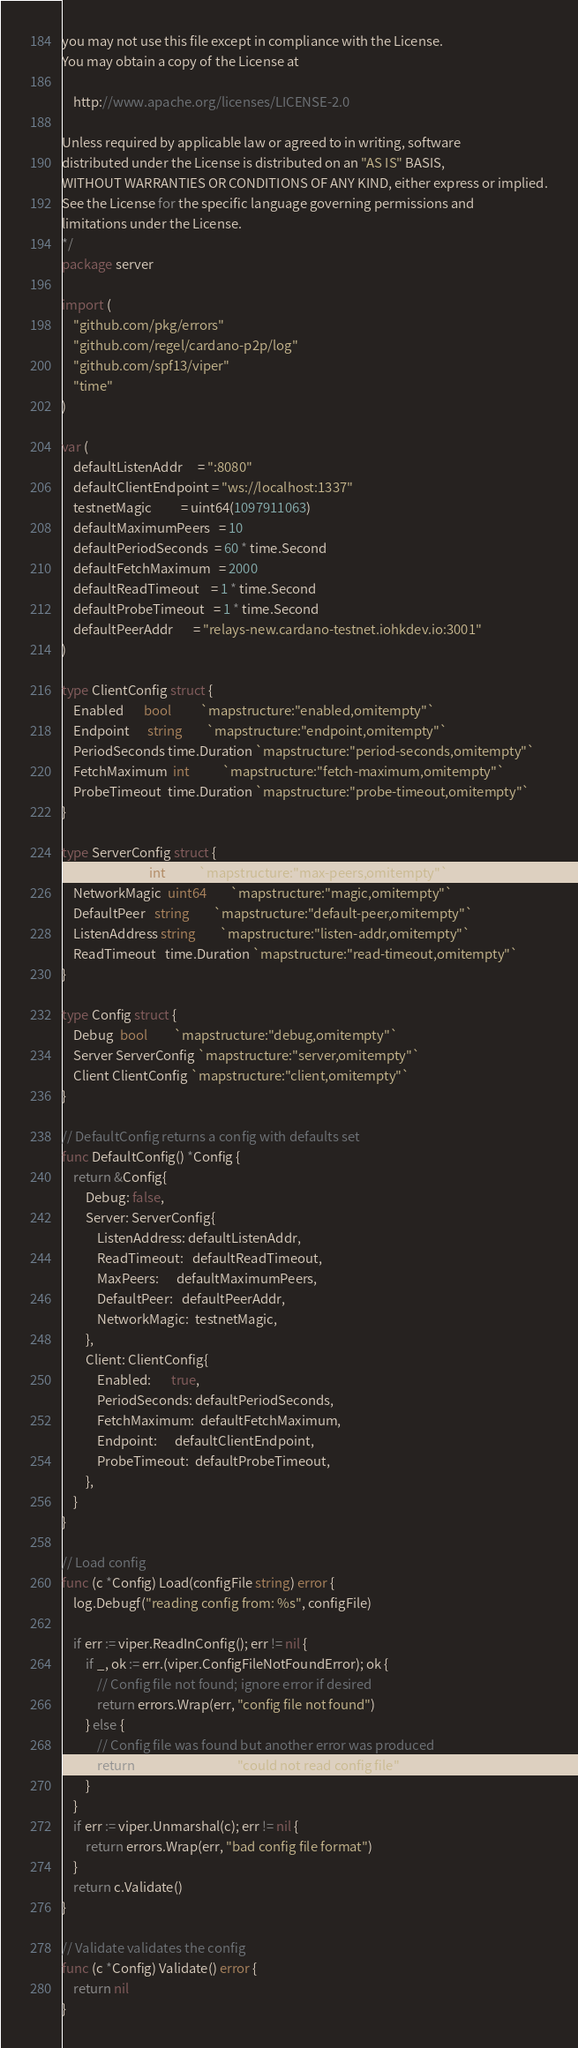Convert code to text. <code><loc_0><loc_0><loc_500><loc_500><_Go_>you may not use this file except in compliance with the License.
You may obtain a copy of the License at

    http://www.apache.org/licenses/LICENSE-2.0

Unless required by applicable law or agreed to in writing, software
distributed under the License is distributed on an "AS IS" BASIS,
WITHOUT WARRANTIES OR CONDITIONS OF ANY KIND, either express or implied.
See the License for the specific language governing permissions and
limitations under the License.
*/
package server

import (
	"github.com/pkg/errors"
	"github.com/regel/cardano-p2p/log"
	"github.com/spf13/viper"
	"time"
)

var (
	defaultListenAddr     = ":8080"
	defaultClientEndpoint = "ws://localhost:1337"
	testnetMagic          = uint64(1097911063)
	defaultMaximumPeers   = 10
	defaultPeriodSeconds  = 60 * time.Second
	defaultFetchMaximum   = 2000
	defaultReadTimeout    = 1 * time.Second
	defaultProbeTimeout   = 1 * time.Second
	defaultPeerAddr       = "relays-new.cardano-testnet.iohkdev.io:3001"
)

type ClientConfig struct {
	Enabled       bool          `mapstructure:"enabled,omitempty"`
	Endpoint      string        `mapstructure:"endpoint,omitempty"`
	PeriodSeconds time.Duration `mapstructure:"period-seconds,omitempty"`
	FetchMaximum  int           `mapstructure:"fetch-maximum,omitempty"`
	ProbeTimeout  time.Duration `mapstructure:"probe-timeout,omitempty"`
}

type ServerConfig struct {
	MaxPeers      int           `mapstructure:"max-peers,omitempty"`
	NetworkMagic  uint64        `mapstructure:"magic,omitempty"`
	DefaultPeer   string        `mapstructure:"default-peer,omitempty"`
	ListenAddress string        `mapstructure:"listen-addr,omitempty"`
	ReadTimeout   time.Duration `mapstructure:"read-timeout,omitempty"`
}

type Config struct {
	Debug  bool         `mapstructure:"debug,omitempty"`
	Server ServerConfig `mapstructure:"server,omitempty"`
	Client ClientConfig `mapstructure:"client,omitempty"`
}

// DefaultConfig returns a config with defaults set
func DefaultConfig() *Config {
	return &Config{
		Debug: false,
		Server: ServerConfig{
			ListenAddress: defaultListenAddr,
			ReadTimeout:   defaultReadTimeout,
			MaxPeers:      defaultMaximumPeers,
			DefaultPeer:   defaultPeerAddr,
			NetworkMagic:  testnetMagic,
		},
		Client: ClientConfig{
			Enabled:       true,
			PeriodSeconds: defaultPeriodSeconds,
			FetchMaximum:  defaultFetchMaximum,
			Endpoint:      defaultClientEndpoint,
			ProbeTimeout:  defaultProbeTimeout,
		},
	}
}

// Load config
func (c *Config) Load(configFile string) error {
	log.Debugf("reading config from: %s", configFile)

	if err := viper.ReadInConfig(); err != nil {
		if _, ok := err.(viper.ConfigFileNotFoundError); ok {
			// Config file not found; ignore error if desired
			return errors.Wrap(err, "config file not found")
		} else {
			// Config file was found but another error was produced
			return errors.Wrap(err, "could not read config file")
		}
	}
	if err := viper.Unmarshal(c); err != nil {
		return errors.Wrap(err, "bad config file format")
	}
	return c.Validate()
}

// Validate validates the config
func (c *Config) Validate() error {
	return nil
}
</code> 